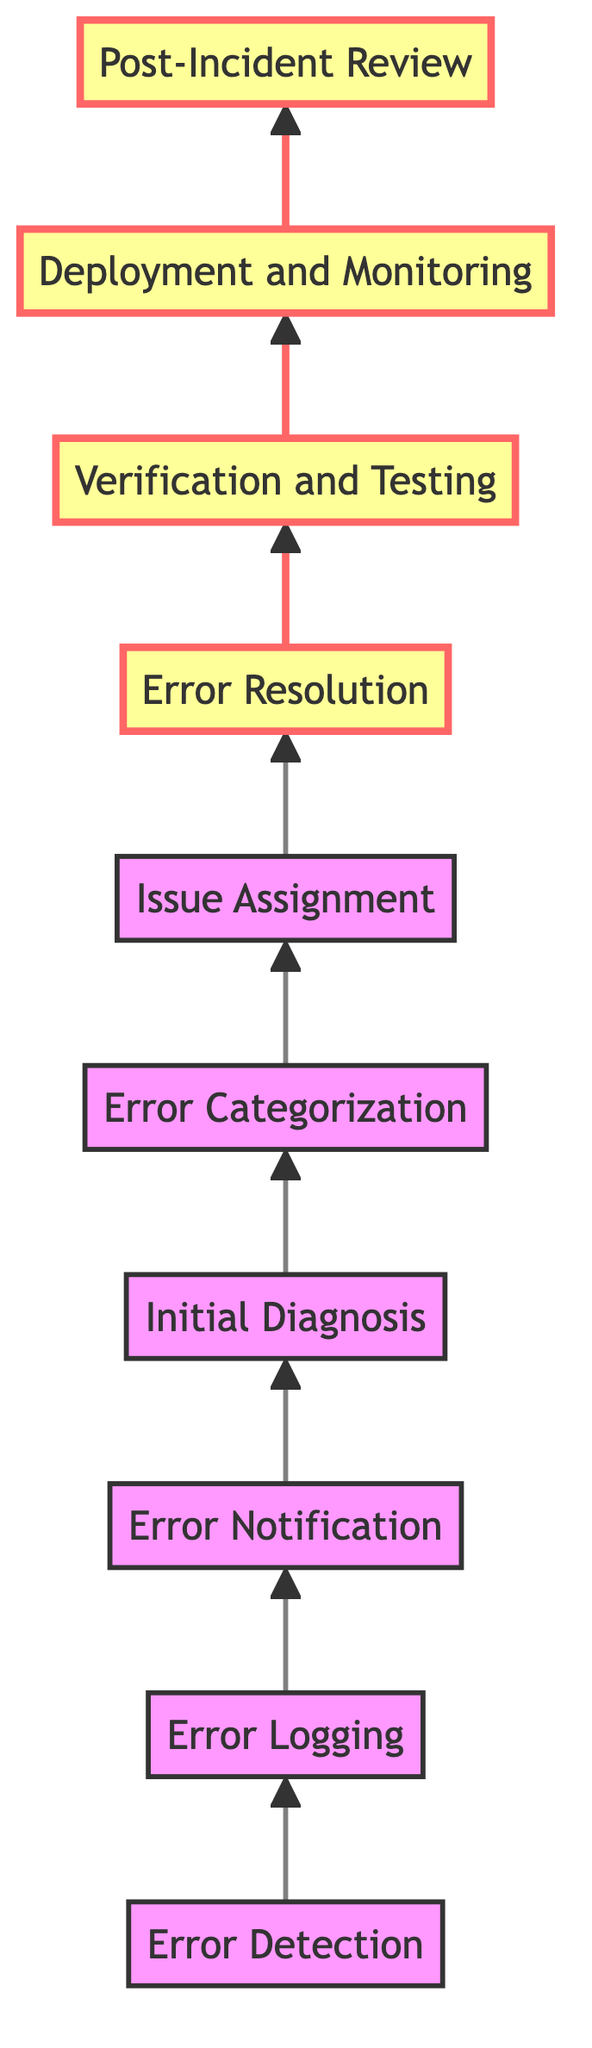What is the first step in the error handling process? The first step in the error handling process, according to the diagram, is "Error Detection." This is the initial action taken to identify server-side errors using monitoring tools.
Answer: Error Detection How many nodes are in the diagram? The diagram contains ten nodes that represent the steps in the server-side error handling process, with each step depicted as a unique node.
Answer: Ten What node follows "Verification and Testing"? After "Verification and Testing," the next node in the flow is "Deployment and Monitoring," indicating that testing is completed before the solution is deployed.
Answer: Deployment and Monitoring Which node is directly before "Error Resolution"? The node directly preceding "Error Resolution" is "Issue Assignment." This indicates that before resolving an error, the issue must be assigned to the appropriate team or individual.
Answer: Issue Assignment How are errors prioritized in this process? Errors are prioritized through the step called "Error Categorization," which classifies them based on severity (critical, high, medium, low) to determine the order of resolution.
Answer: Error Categorization What is the last step in the error handling process? The last step in the error handling process is "Post-Incident Review," which serves to evaluate the incident and improve future error handling.
Answer: Post-Incident Review Which two nodes involve communication tools? The nodes involving communication tools are "Error Notification," where alerts are sent, and "Issue Assignment," where the issue is communicated to the relevant team through project management tools.
Answer: Error Notification and Issue Assignment What happens directly after "Initial Diagnosis"? After "Initial Diagnosis," the process moves to "Error Categorization," where the identified errors are classified based on severity.
Answer: Error Categorization Which nodes are highlighted in the diagram? The highlighted nodes in the diagram are "Error Resolution," "Verification and Testing," "Deployment and Monitoring," and "Post-Incident Review," indicating their importance in the process.
Answer: Error Resolution, Verification and Testing, Deployment and Monitoring, Post-Incident Review 